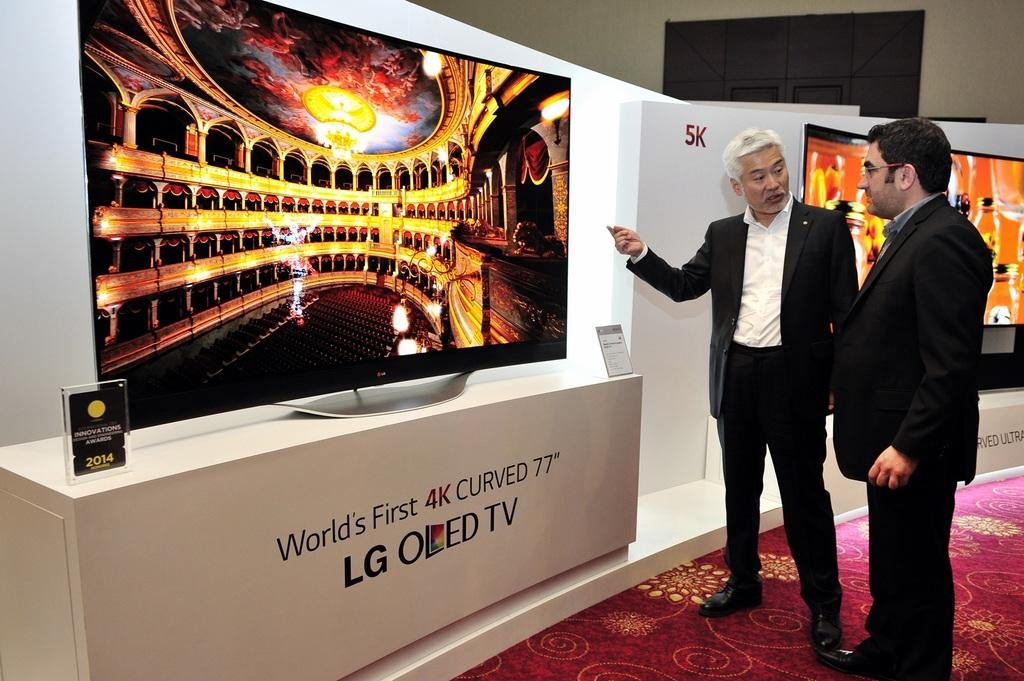<image>
Offer a succinct explanation of the picture presented. an LG OED tv that is next to the carpet 